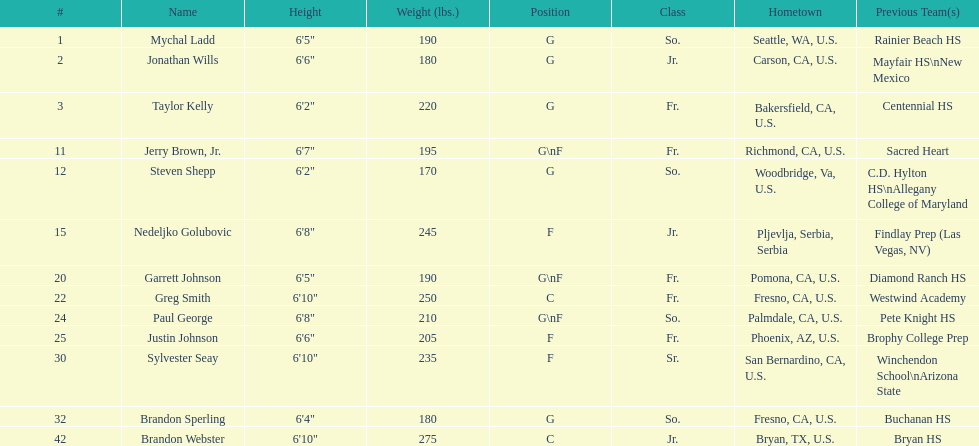How many players and both guard (g) and forward (f)? 3. Would you be able to parse every entry in this table? {'header': ['#', 'Name', 'Height', 'Weight (lbs.)', 'Position', 'Class', 'Hometown', 'Previous Team(s)'], 'rows': [['1', 'Mychal Ladd', '6\'5"', '190', 'G', 'So.', 'Seattle, WA, U.S.', 'Rainier Beach HS'], ['2', 'Jonathan Wills', '6\'6"', '180', 'G', 'Jr.', 'Carson, CA, U.S.', 'Mayfair HS\\nNew Mexico'], ['3', 'Taylor Kelly', '6\'2"', '220', 'G', 'Fr.', 'Bakersfield, CA, U.S.', 'Centennial HS'], ['11', 'Jerry Brown, Jr.', '6\'7"', '195', 'G\\nF', 'Fr.', 'Richmond, CA, U.S.', 'Sacred Heart'], ['12', 'Steven Shepp', '6\'2"', '170', 'G', 'So.', 'Woodbridge, Va, U.S.', 'C.D. Hylton HS\\nAllegany College of Maryland'], ['15', 'Nedeljko Golubovic', '6\'8"', '245', 'F', 'Jr.', 'Pljevlja, Serbia, Serbia', 'Findlay Prep (Las Vegas, NV)'], ['20', 'Garrett Johnson', '6\'5"', '190', 'G\\nF', 'Fr.', 'Pomona, CA, U.S.', 'Diamond Ranch HS'], ['22', 'Greg Smith', '6\'10"', '250', 'C', 'Fr.', 'Fresno, CA, U.S.', 'Westwind Academy'], ['24', 'Paul George', '6\'8"', '210', 'G\\nF', 'So.', 'Palmdale, CA, U.S.', 'Pete Knight HS'], ['25', 'Justin Johnson', '6\'6"', '205', 'F', 'Fr.', 'Phoenix, AZ, U.S.', 'Brophy College Prep'], ['30', 'Sylvester Seay', '6\'10"', '235', 'F', 'Sr.', 'San Bernardino, CA, U.S.', 'Winchendon School\\nArizona State'], ['32', 'Brandon Sperling', '6\'4"', '180', 'G', 'So.', 'Fresno, CA, U.S.', 'Buchanan HS'], ['42', 'Brandon Webster', '6\'10"', '275', 'C', 'Jr.', 'Bryan, TX, U.S.', 'Bryan HS']]} 